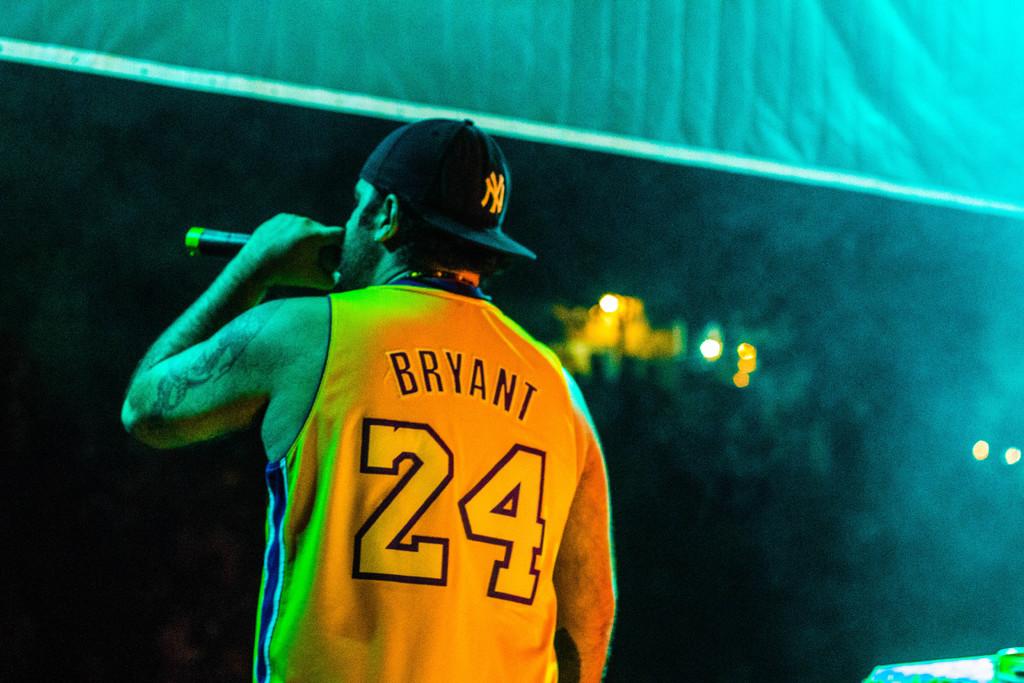What name is on the basketball jersey?
Provide a short and direct response. Bryant. What number is on the jersey?
Offer a terse response. 24. 